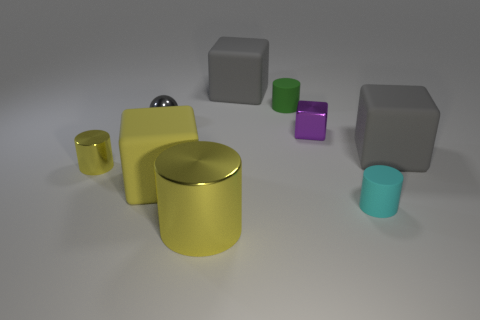What materials appear to be present in the objects displayed in the image? The objects in the image seem to be made from various materials. The yellowish objects—a cup and a cylinder—display a glossy finish suggestive of a polished metallic or plastic substance. The small purple and green blocks, along with two grey cubes, have a matte finish consistent with plastic or painted wood. Lastly, the silver sphere in the center has a reflective surface that indicates a metallic composition. 